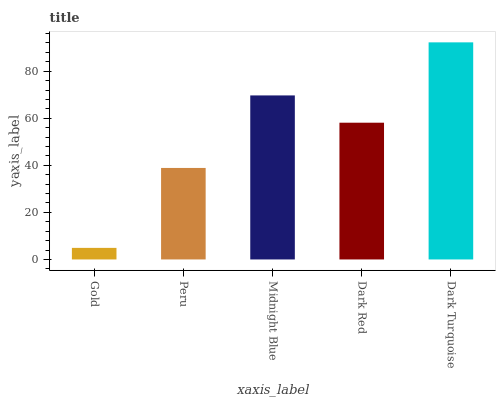Is Gold the minimum?
Answer yes or no. Yes. Is Dark Turquoise the maximum?
Answer yes or no. Yes. Is Peru the minimum?
Answer yes or no. No. Is Peru the maximum?
Answer yes or no. No. Is Peru greater than Gold?
Answer yes or no. Yes. Is Gold less than Peru?
Answer yes or no. Yes. Is Gold greater than Peru?
Answer yes or no. No. Is Peru less than Gold?
Answer yes or no. No. Is Dark Red the high median?
Answer yes or no. Yes. Is Dark Red the low median?
Answer yes or no. Yes. Is Peru the high median?
Answer yes or no. No. Is Dark Turquoise the low median?
Answer yes or no. No. 